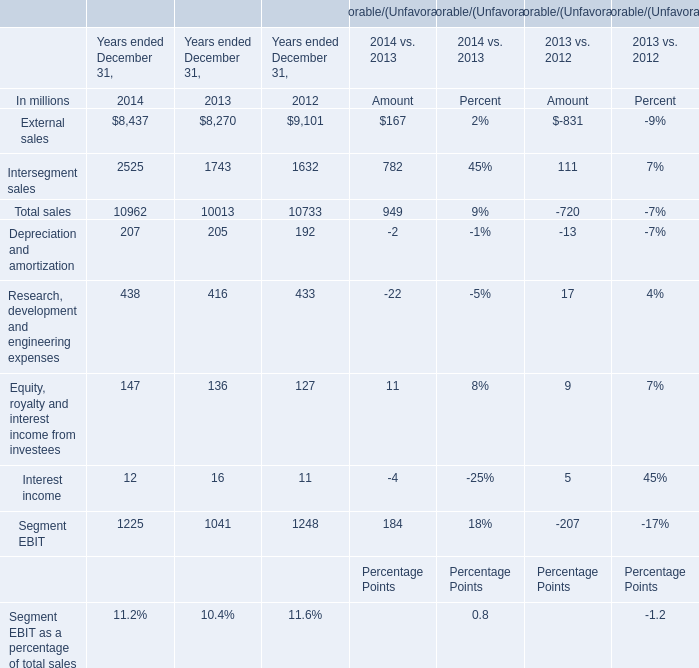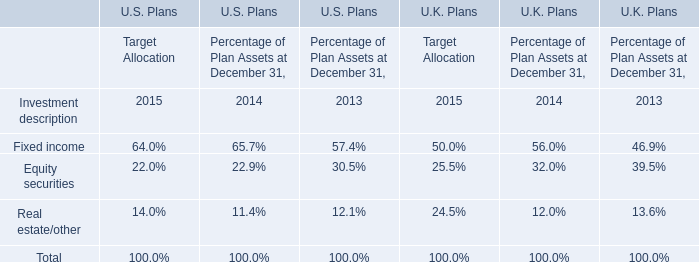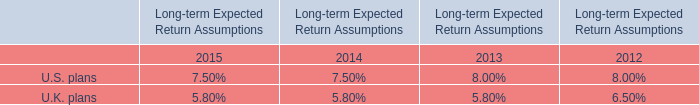What will External sales be like in 2015 if it develops with the same increasing rate as current? (in million) 
Computations: (8437 + ((8437 * (8437 - 8270)) / 8270))
Answer: 8607.37231. 